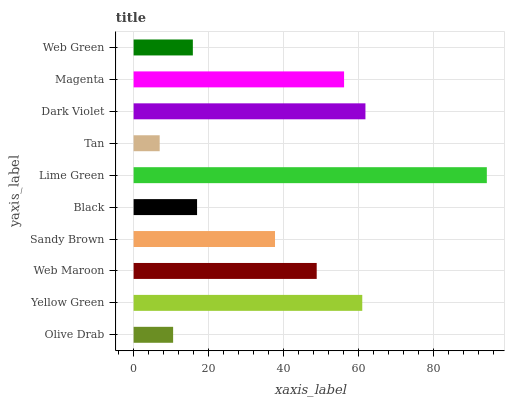Is Tan the minimum?
Answer yes or no. Yes. Is Lime Green the maximum?
Answer yes or no. Yes. Is Yellow Green the minimum?
Answer yes or no. No. Is Yellow Green the maximum?
Answer yes or no. No. Is Yellow Green greater than Olive Drab?
Answer yes or no. Yes. Is Olive Drab less than Yellow Green?
Answer yes or no. Yes. Is Olive Drab greater than Yellow Green?
Answer yes or no. No. Is Yellow Green less than Olive Drab?
Answer yes or no. No. Is Web Maroon the high median?
Answer yes or no. Yes. Is Sandy Brown the low median?
Answer yes or no. Yes. Is Sandy Brown the high median?
Answer yes or no. No. Is Black the low median?
Answer yes or no. No. 